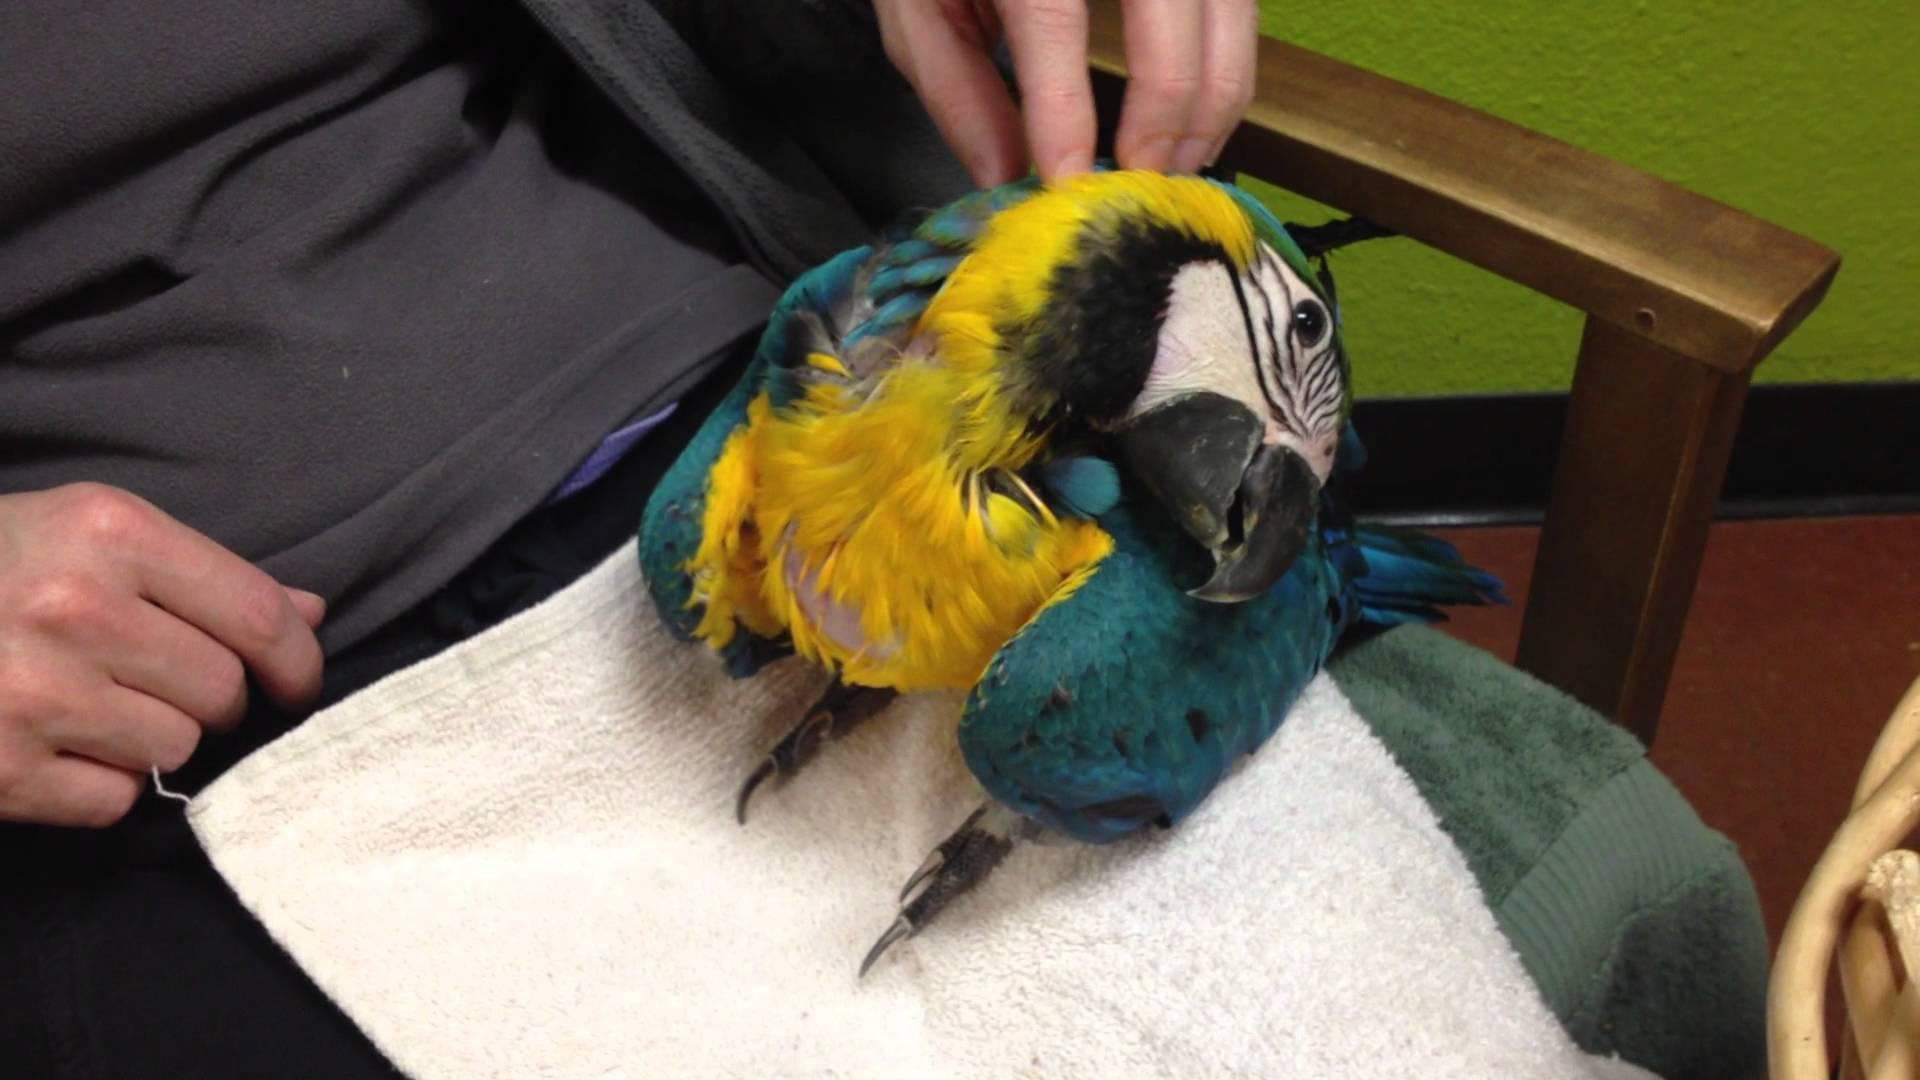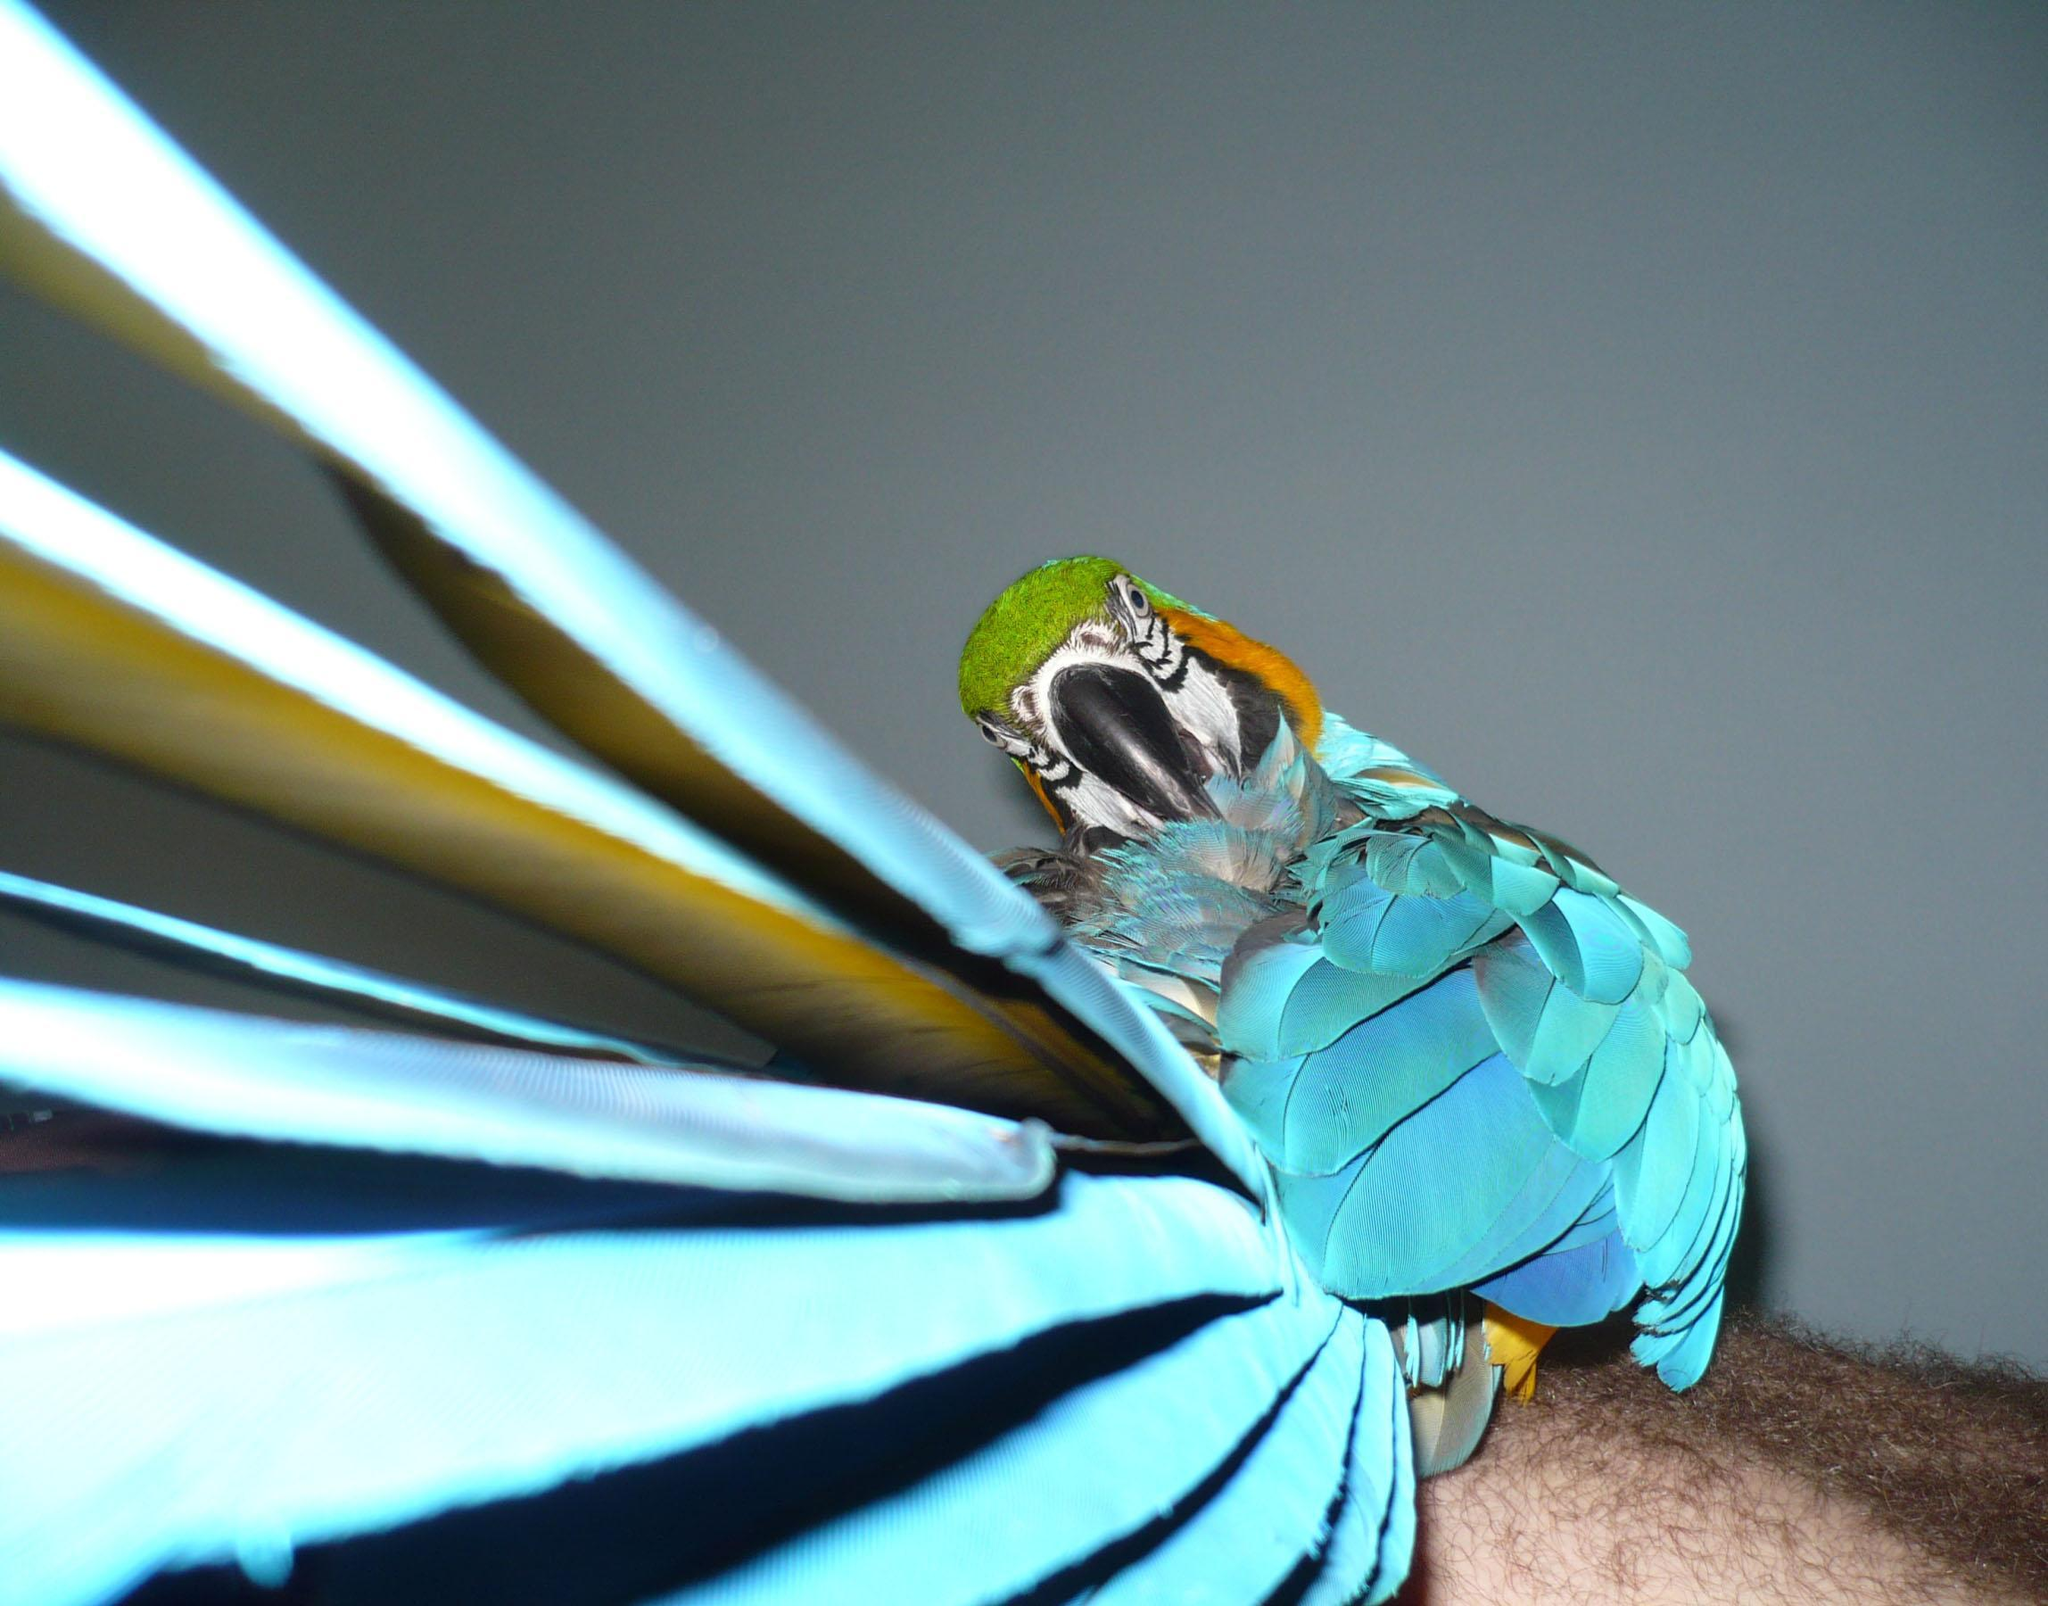The first image is the image on the left, the second image is the image on the right. Evaluate the accuracy of this statement regarding the images: "A parrot with a red head is sleeping outdoors.". Is it true? Answer yes or no. No. The first image is the image on the left, the second image is the image on the right. Examine the images to the left and right. Is the description "The parrot in the right image has a red head." accurate? Answer yes or no. No. 